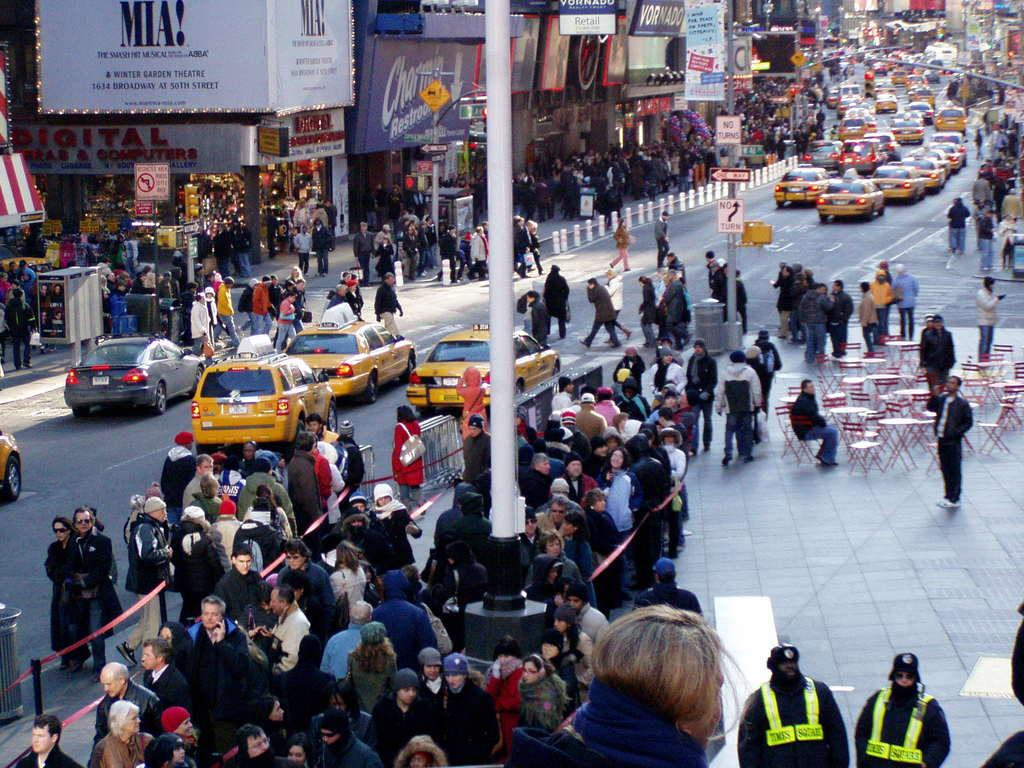<image>
Give a short and clear explanation of the subsequent image. A busy street and a sign saying MIA! Winter Garden Theatre. 